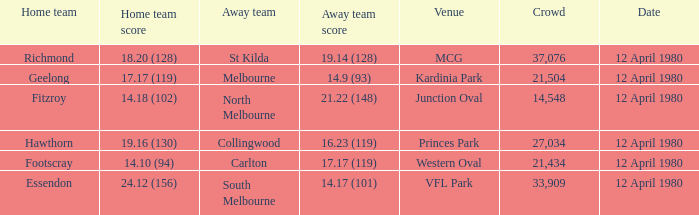In what place did essendon compete as the home side? VFL Park. 